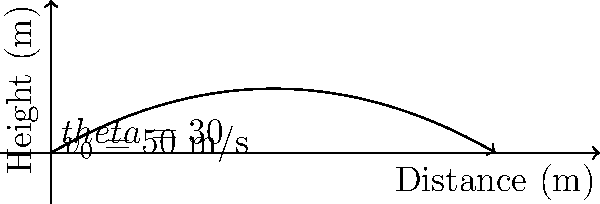In an archery competition, you launch an arrow with an initial velocity of 50 m/s at an angle of 30° above the horizontal. Assuming no air resistance, calculate the maximum height reached by the arrow. How does this relate to the traditional Turkish archery techniques you've studied? To solve this problem, we'll follow these steps:

1) The vertical component of the initial velocity is:
   $v_{0y} = v_0 \sin(\theta) = 50 \cdot \sin(30°) = 25$ m/s

2) The time to reach the maximum height is when the vertical velocity becomes zero:
   $t_{max} = \frac{v_{0y}}{g} = \frac{25}{9.81} \approx 2.55$ s

3) The maximum height can be calculated using the equation:
   $h_{max} = v_{0y} \cdot t_{max} - \frac{1}{2} g \cdot t_{max}^2$

4) Substituting the values:
   $h_{max} = 25 \cdot 2.55 - \frac{1}{2} \cdot 9.81 \cdot 2.55^2$
   $h_{max} = 63.75 - 31.875 = 31.875$ m

5) Rounding to two decimal places:
   $h_{max} \approx 31.88$ m

This result demonstrates the importance of launch angle and initial velocity in archery, which are crucial elements in traditional Turkish archery. Turkish archers historically used composite bows capable of imparting high initial velocities to arrows, allowing for long-range shots and high trajectories. Understanding these principles helps modern Turkish archers optimize their technique and equipment choices.
Answer: 31.88 m 